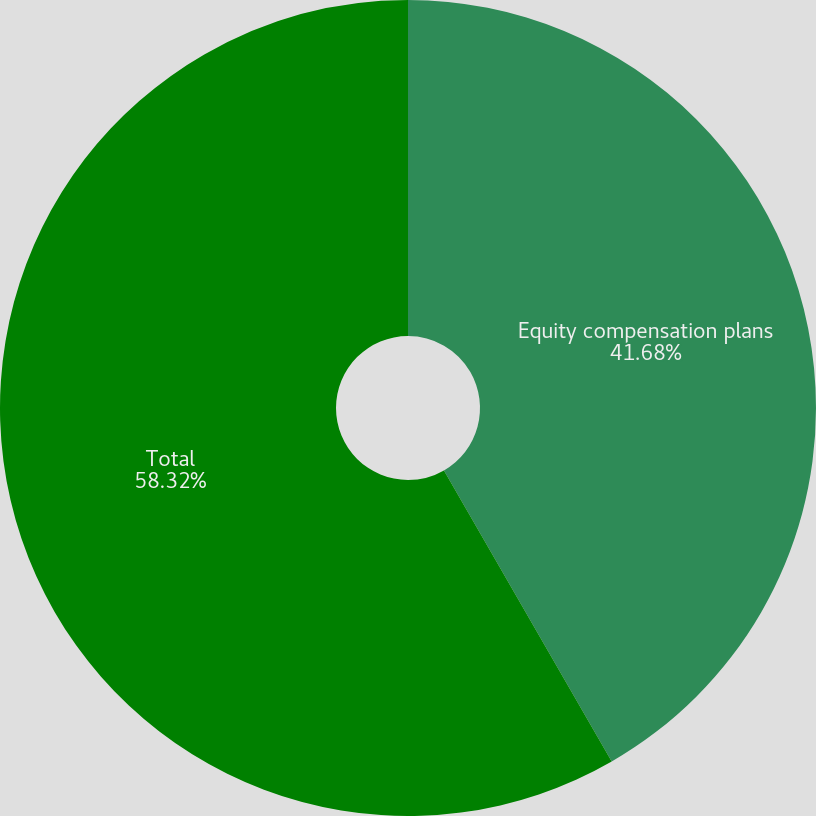Convert chart. <chart><loc_0><loc_0><loc_500><loc_500><pie_chart><fcel>Equity compensation plans<fcel>Total<nl><fcel>41.68%<fcel>58.32%<nl></chart> 